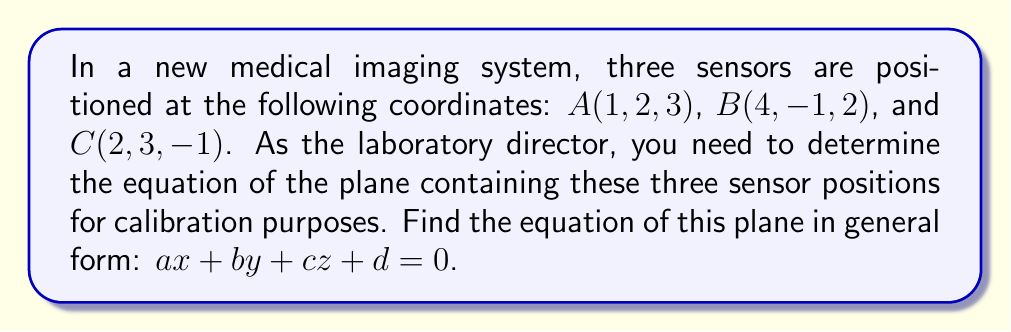Can you answer this question? To find the equation of a plane containing three points, we can follow these steps:

1) First, we need to find two vectors on the plane. We can do this by subtracting the coordinates of two points from the third:

   $\vec{AB} = B - A = (4-1, -1-2, 2-3) = (3, -3, -1)$
   $\vec{AC} = C - A = (2-1, 3-2, -1-3) = (1, 1, -4)$

2) The normal vector to the plane will be the cross product of these two vectors:

   $\vec{n} = \vec{AB} \times \vec{AC} = \begin{vmatrix} 
   i & j & k \\
   3 & -3 & -1 \\
   1 & 1 & -4
   \end{vmatrix}$

   $= ((-3)(-4) - (-1)(1))i - (3(-4) - (-1)(1))j + (3(1) - (-3)(1))k$
   $= (12 - (-1))i - (-12 - 1)j + (3 - (-3))k$
   $= 13i + 11j + 6k$

3) So, the normal vector is $\vec{n} = (13, 11, 6)$. These coefficients will be $a$, $b$, and $c$ in our plane equation.

4) Now we can use the general form of a plane equation:

   $ax + by + cz + d = 0$

   Where $(x, y, z)$ is any point on the plane. We can use point $A(1, 2, 3)$ to find $d$:

   $13(1) + 11(2) + 6(3) + d = 0$
   $13 + 22 + 18 + d = 0$
   $53 + d = 0$
   $d = -53$

5) Therefore, the equation of the plane is:

   $13x + 11y + 6z - 53 = 0$
Answer: $13x + 11y + 6z - 53 = 0$ 